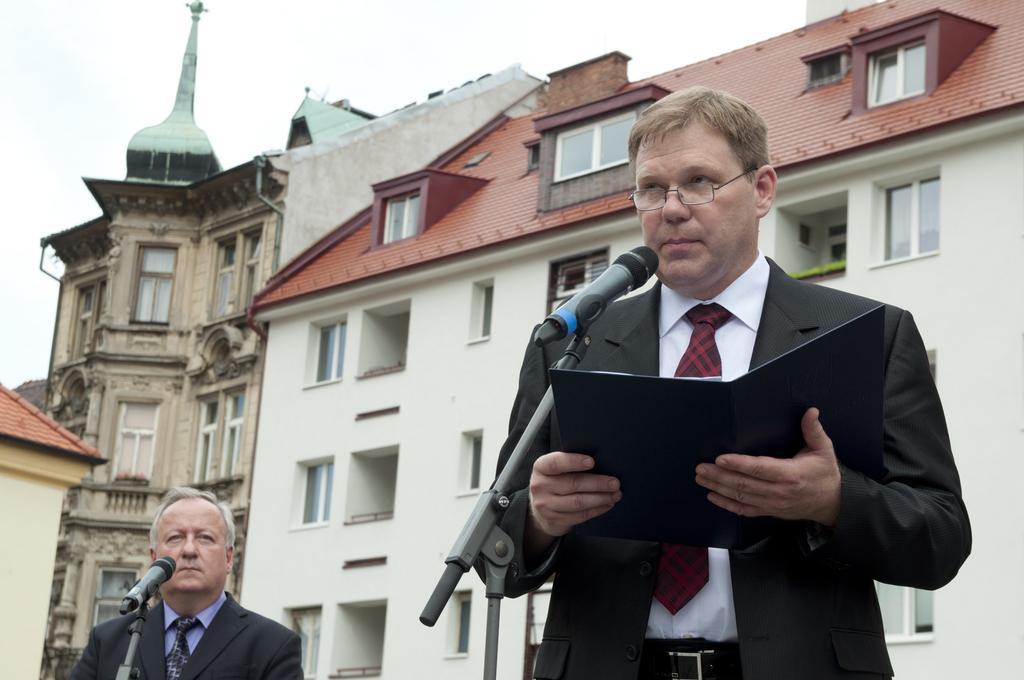Describe this image in one or two sentences. In this picture there is a man wearing a black color coat and holding a book in hand, giving a speech on the microphone. Behind there is a white color building with red roof tiles. On the left side there is another man standing near the microphone. 